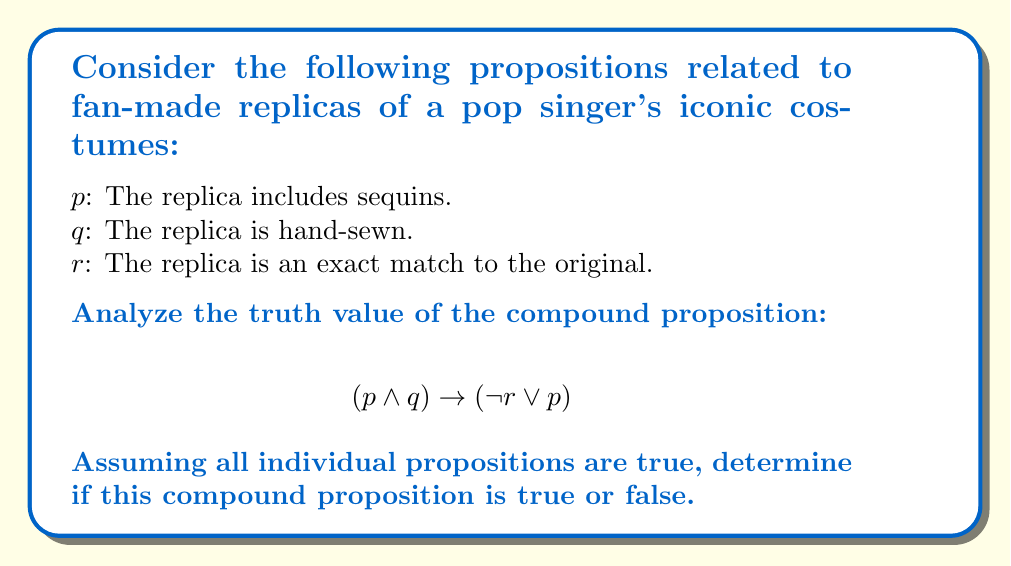Give your solution to this math problem. Let's break this down step-by-step:

1) First, we need to evaluate the truth values of the individual propositions:
   $p$ is true (T)
   $q$ is true (T)
   $r$ is true (T)

2) Now, let's evaluate the left side of the implication: $(p \wedge q)$
   $T \wedge T = T$

3) Next, let's evaluate the right side of the implication: $(\neg r \vee p)$
   $\neg r$ is false (F) because $r$ is true
   $F \vee T = T$

4) Now we have the implication: $T \rightarrow T$

5) Recall the truth table for implication:
   
   | $P$ | $Q$ | $P \rightarrow Q$ |
   |-----|-----|-------------------|
   | T   | T   | T                 |
   | T   | F   | F                 |
   | F   | T   | T                 |
   | F   | F   | T                 |

6) In our case, we have $T \rightarrow T$, which is true according to the truth table.

Therefore, the compound proposition $(p \wedge q) \rightarrow (\neg r \vee p)$ is true when all individual propositions are true.
Answer: True 